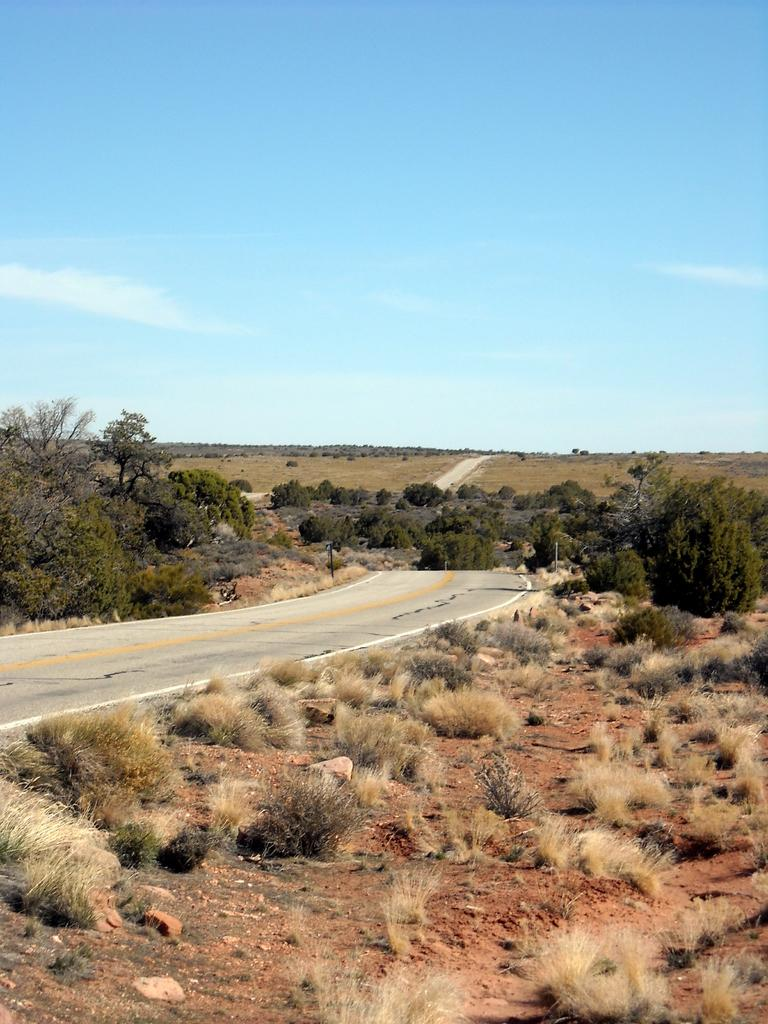What type of pathway is visible in the image? There is a road in the image. What type of vegetation can be seen in the image? There is dried grass, trees, and bushes visible in the image. What part of the natural environment is visible in the image? The sky is visible in the image. What type of jewel can be seen in the image? There is no jewel present in the image. What type of insurance policy is being advertised in the image? There is no advertisement or reference to insurance in the image. 